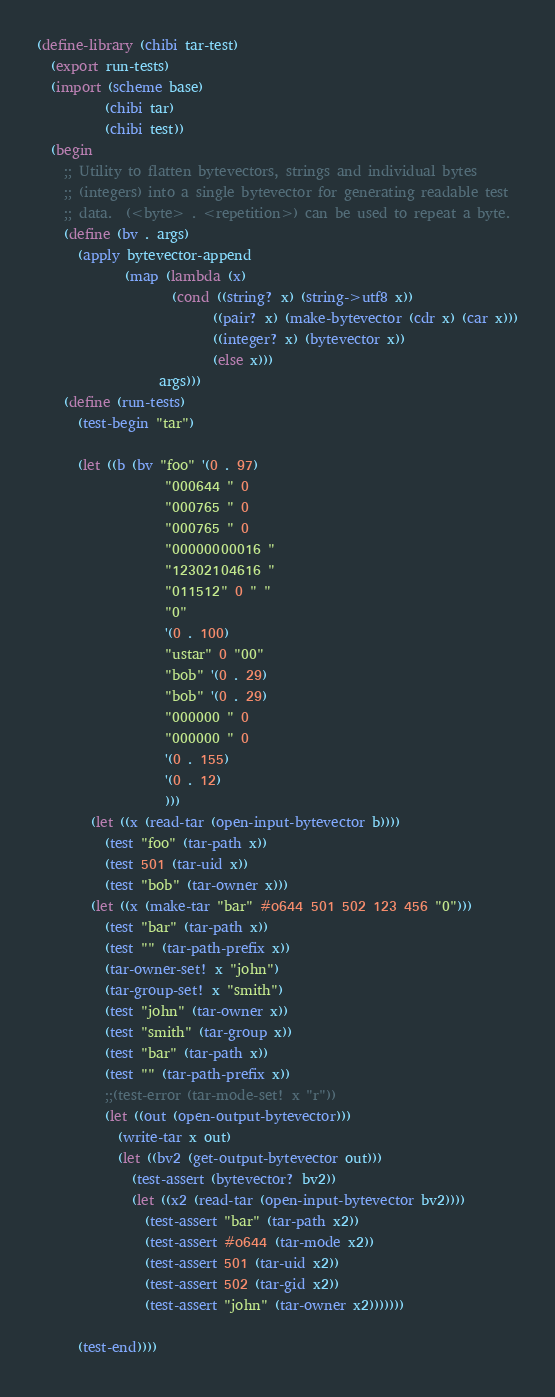<code> <loc_0><loc_0><loc_500><loc_500><_Scheme_>(define-library (chibi tar-test)
  (export run-tests)
  (import (scheme base)
          (chibi tar)
          (chibi test))
  (begin
    ;; Utility to flatten bytevectors, strings and individual bytes
    ;; (integers) into a single bytevector for generating readable test
    ;; data.  (<byte> . <repetition>) can be used to repeat a byte.
    (define (bv . args)
      (apply bytevector-append
             (map (lambda (x)
                    (cond ((string? x) (string->utf8 x))
                          ((pair? x) (make-bytevector (cdr x) (car x)))
                          ((integer? x) (bytevector x))
                          (else x)))
                  args)))
    (define (run-tests)
      (test-begin "tar")

      (let ((b (bv "foo" '(0 . 97)
                   "000644 " 0
                   "000765 " 0
                   "000765 " 0
                   "00000000016 "
                   "12302104616 "
                   "011512" 0 " "
                   "0"
                   '(0 . 100)
                   "ustar" 0 "00"
                   "bob" '(0 . 29)
                   "bob" '(0 . 29)
                   "000000 " 0
                   "000000 " 0
                   '(0 . 155)
                   '(0 . 12)
                   )))
        (let ((x (read-tar (open-input-bytevector b))))
          (test "foo" (tar-path x))
          (test 501 (tar-uid x))
          (test "bob" (tar-owner x)))
        (let ((x (make-tar "bar" #o644 501 502 123 456 "0")))
          (test "bar" (tar-path x))
          (test "" (tar-path-prefix x))
          (tar-owner-set! x "john")
          (tar-group-set! x "smith")
          (test "john" (tar-owner x))
          (test "smith" (tar-group x))
          (test "bar" (tar-path x))
          (test "" (tar-path-prefix x))
          ;;(test-error (tar-mode-set! x "r"))
          (let ((out (open-output-bytevector)))
            (write-tar x out)
            (let ((bv2 (get-output-bytevector out)))
              (test-assert (bytevector? bv2))
              (let ((x2 (read-tar (open-input-bytevector bv2))))
                (test-assert "bar" (tar-path x2))
                (test-assert #o644 (tar-mode x2))
                (test-assert 501 (tar-uid x2))
                (test-assert 502 (tar-gid x2))
                (test-assert "john" (tar-owner x2)))))))

      (test-end))))
</code> 